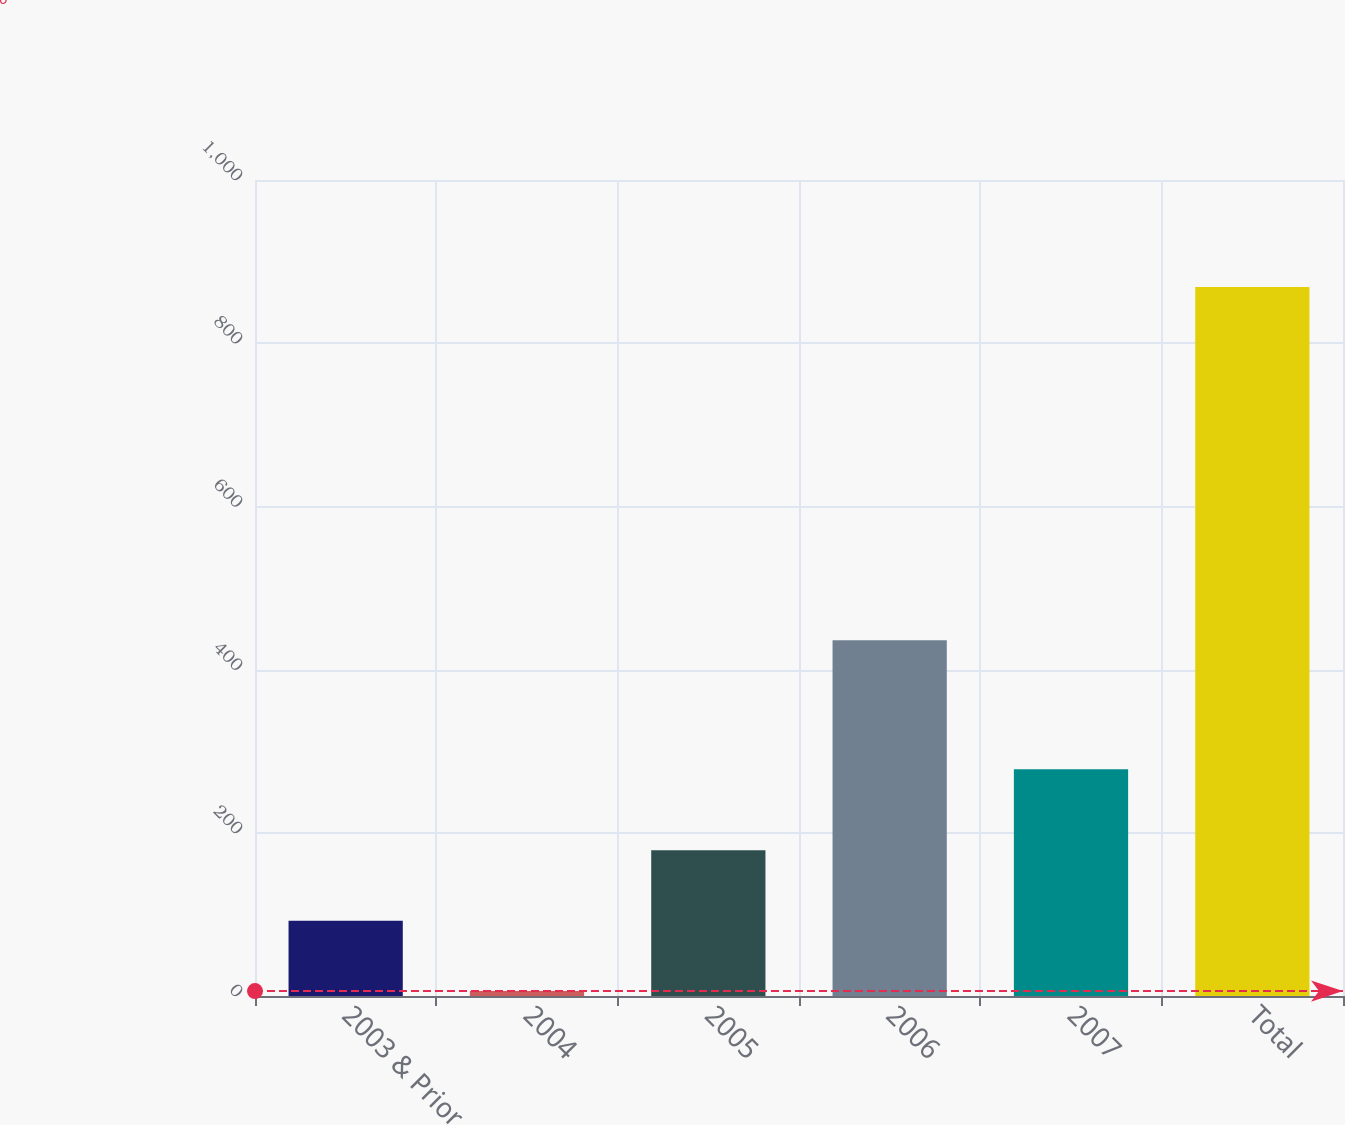<chart> <loc_0><loc_0><loc_500><loc_500><bar_chart><fcel>2003 & Prior<fcel>2004<fcel>2005<fcel>2006<fcel>2007<fcel>Total<nl><fcel>92.3<fcel>6<fcel>178.6<fcel>436<fcel>278<fcel>869<nl></chart> 